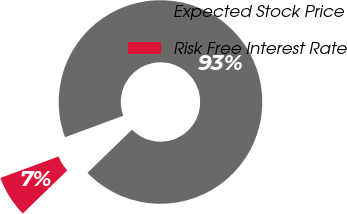<chart> <loc_0><loc_0><loc_500><loc_500><pie_chart><fcel>Expected Stock Price<fcel>Risk Free Interest Rate<nl><fcel>93.37%<fcel>6.63%<nl></chart> 